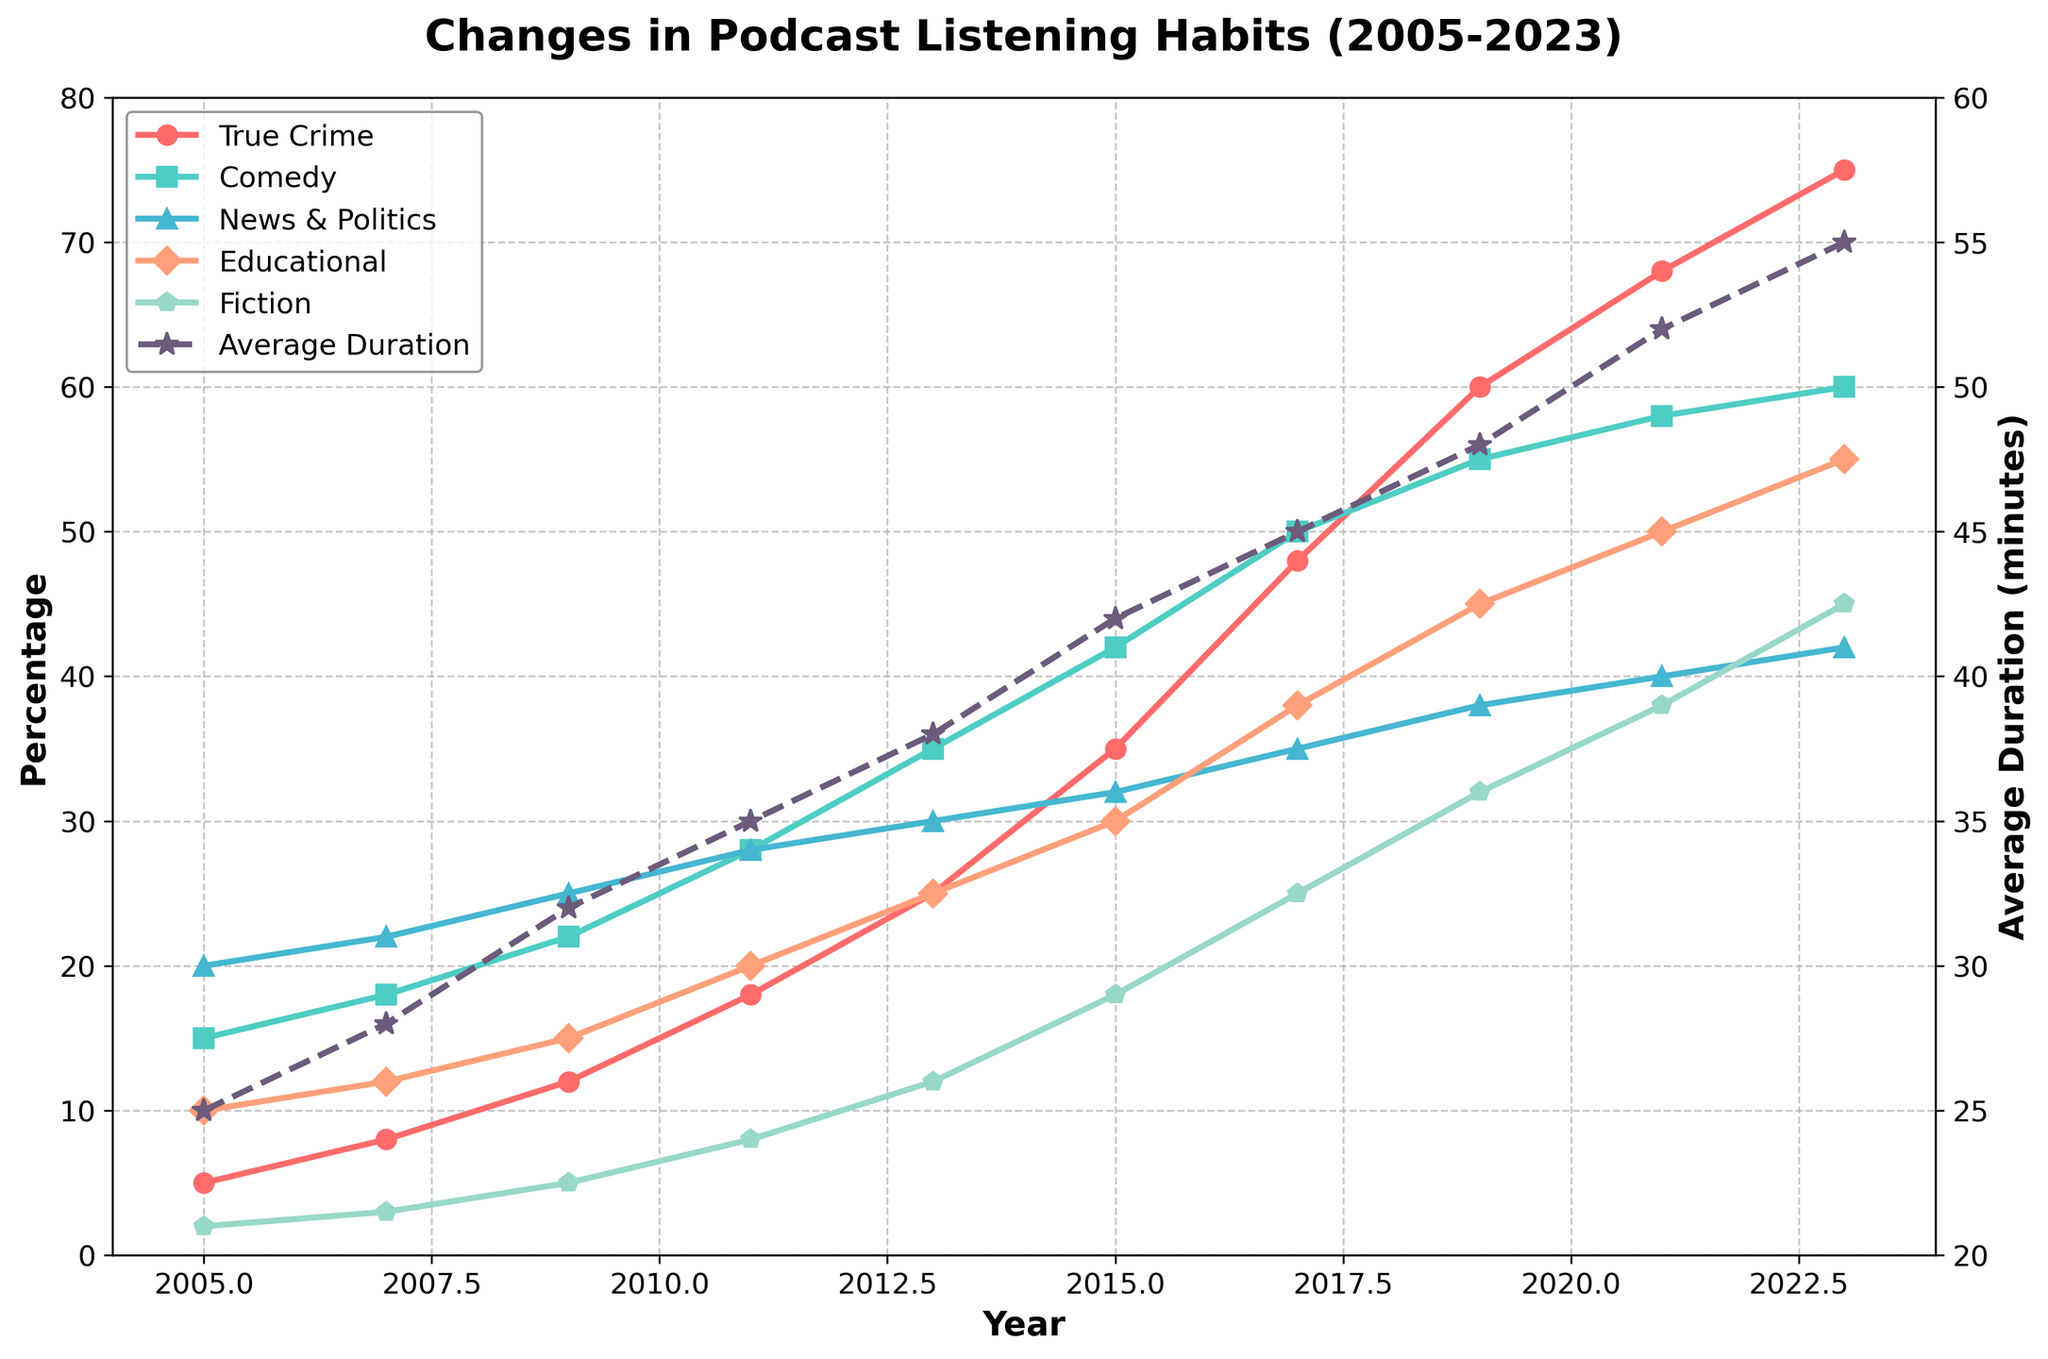What is the percentage increase in True Crime podcast listening from 2005 to 2023? First, note the percentage of True Crime listening in 2005 (5%). Then, note the percentage in 2023 (75%). Calculate the increase by subtracting the 2005 value from the 2023 value (75% - 5% = 70%).
Answer: 70% Which genre saw the highest percentage increase in listening habits from 2005 to 2023? Examine the starting and ending percentages for each genre. Compute the increase for True Crime (75% - 5% = 70%), Comedy (60% - 15% = 45%), News & Politics (42% - 20% = 22%), Educational (55% - 10% = 45%), and Fiction (45% - 2% = 43%). True Crime has the highest increase.
Answer: True Crime Comparing 2011 and 2019, which genre had a greater percentage increase, Comedy or Educational? For Comedy, the increase from 2011 (28%) to 2019 (55%) is 27%. For Educational, the increase from 2011 (20%) to 2019 (45%) is 25%.
Answer: Comedy What is the average duration of podcasts in 2015 compared to 2023? Locate the average duration in 2015 (42 minutes) and 2023 (55 minutes).
Answer: 42 minutes in 2015, 55 minutes in 2023 In which year did the News & Politics genre surpass the 30% listening threshold? Notice that the News & Politics genre surpassed 30% in 2013 and maintained it in subsequent years.
Answer: 2013 How does the change in Educational podcast listening from 2005 to 2015 compare to the change in Fiction podcast listening over the same period? Calculate the increase for Educational from 2005 (10%) to 2015 (30%) which is 20%. For Fiction, the increase from 2005 (2%) to 2015 (18%) is 16%.
Answer: Educational: 20%, Fiction: 16% Which genre had the smallest increase in percentage from 2005 to 2007? Determine the increase for each genre between 2005 and 2007: True Crime (3%), Comedy (3%), News & Politics (2%), Educational (2%), Fiction (1%). Fiction had the smallest increase.
Answer: Fiction How does the average duration of podcasts in 2017 compare to the average duration in 2021? The average duration in 2017 is 45 minutes, and in 2021 it is 52 minutes. Compare the two values.
Answer: 45 minutes in 2017, 52 minutes in 2021 Between News & Politics and Fiction, which genre has a steeper growth rate from 2015 to 2023? Calculate the increase for News & Politics (42% - 32% = 10%) and Fiction (45% - 18% = 27%). Fiction has a steeper growth rate.
Answer: Fiction Which genre shows a continuous increase in listening percentage every two years? Inspect each genre's trend over the years for consistent increases every two years. True Crime shows continuous growth without decline.
Answer: True Crime 